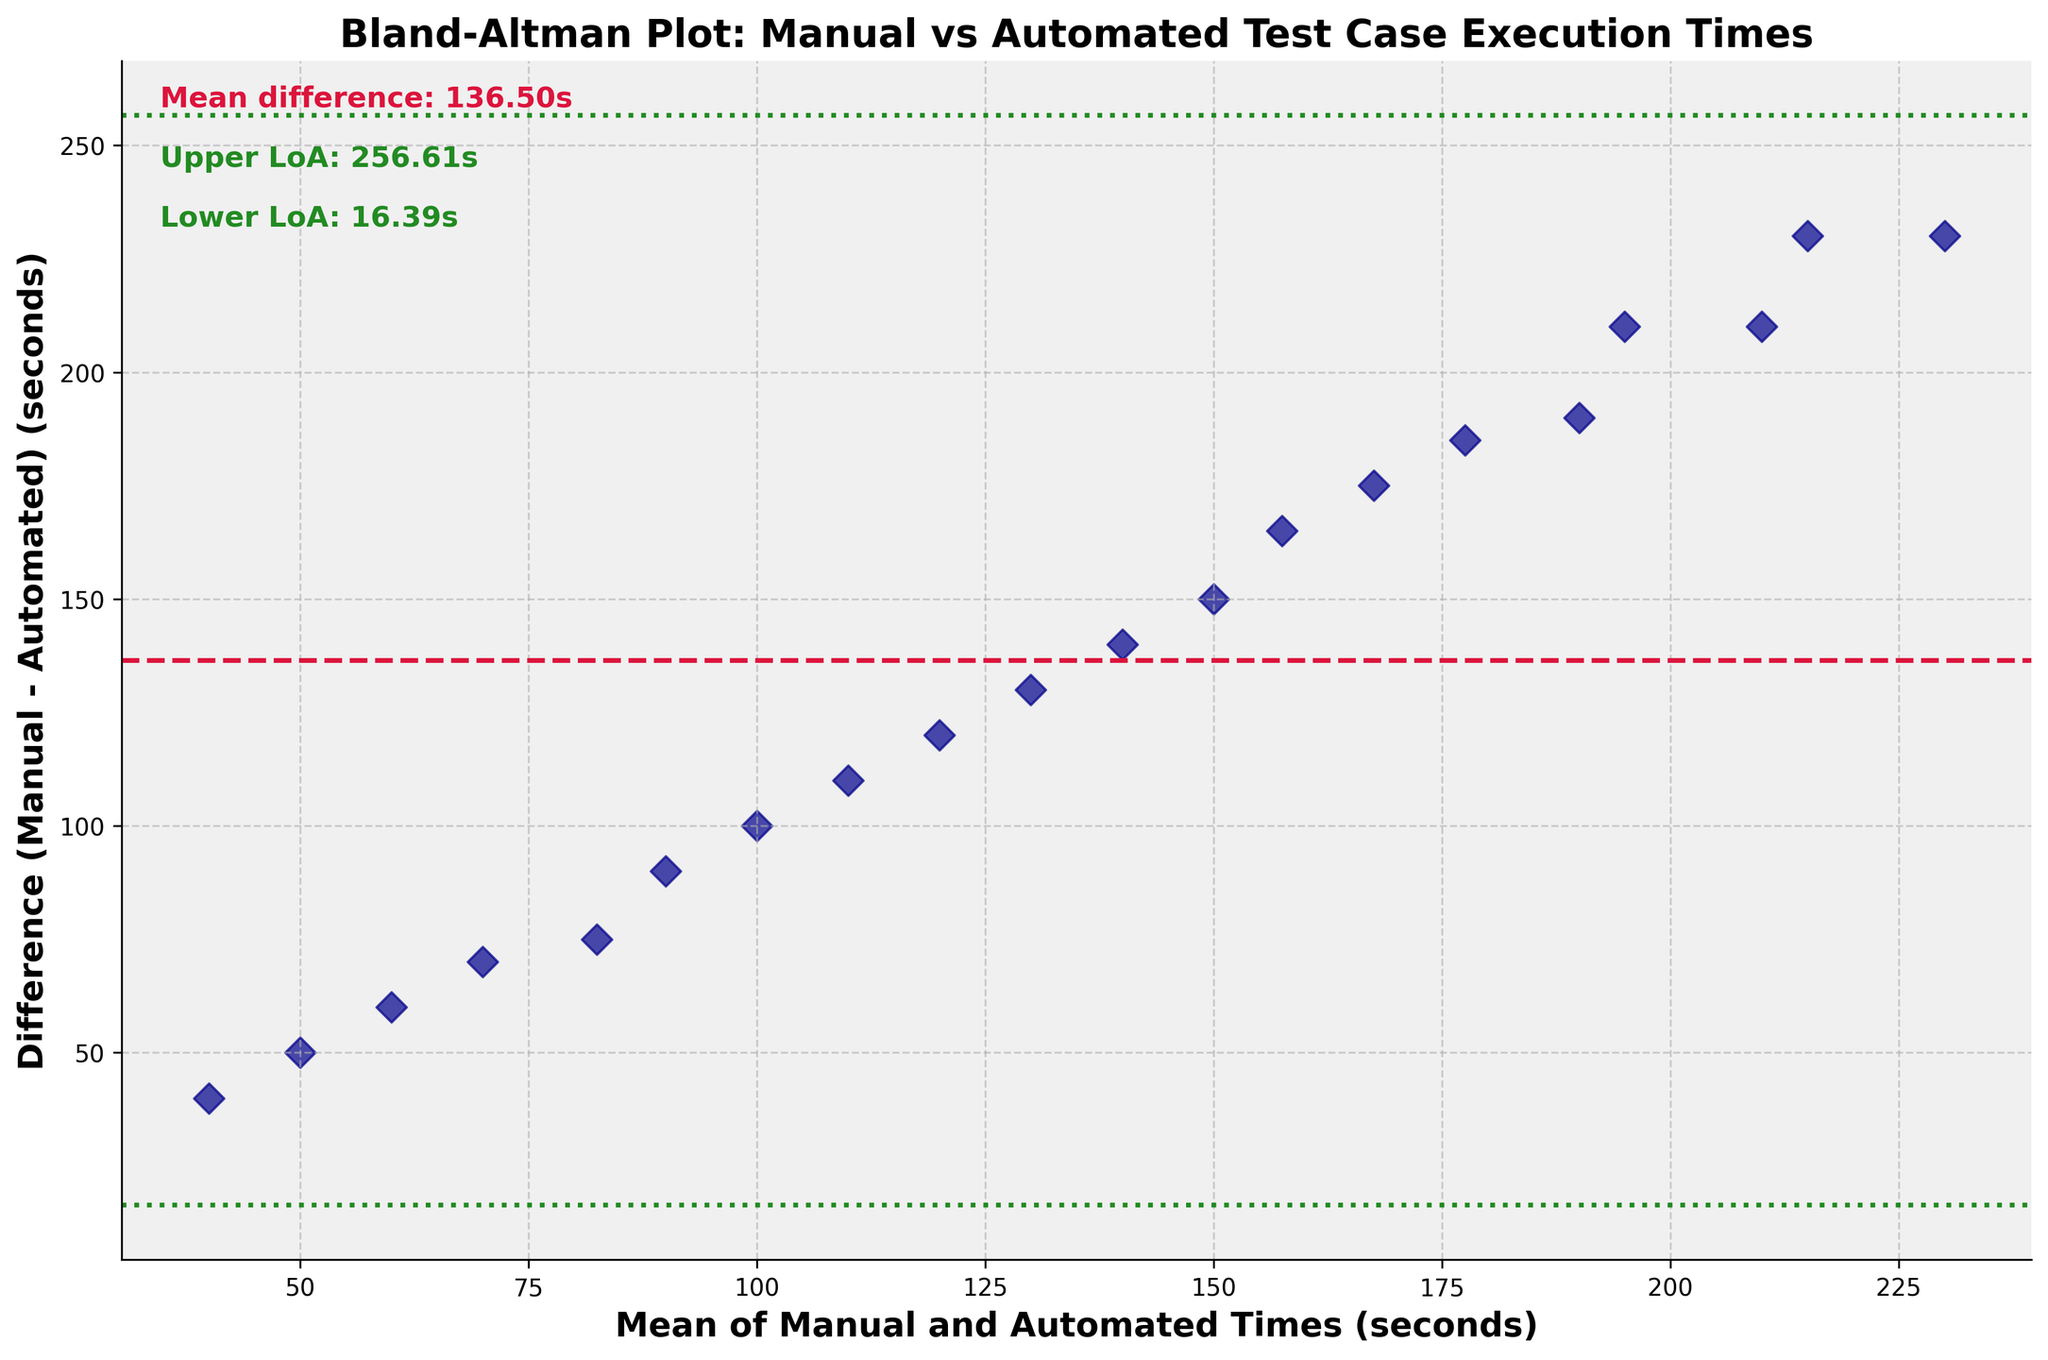What does the title of the plot indicate? The title "Bland-Altman Plot: Manual vs Automated Test Case Execution Times" indicates that this plot compares the execution times of test cases when run manually versus automatically.
Answer: It compares manual and automated test execution times How many data points are represented in the plot? By counting the individual dots scattered in the plot, one can see that there are 20 data points.
Answer: 20 What do the x-axis and y-axis represent in the plot? The x-axis represents the mean of manual and automated times in seconds, while the y-axis represents the difference between manual and automated times (manual time - automated time) in seconds.
Answer: Mean of times (x), Difference in times (y) What is the mean difference between manual and automated test execution times? The mean difference is represented by the horizontal dashed line, which is labeled as "Mean difference: 146.25s" on the plot.
Answer: 146.25 seconds Where are the limits of agreement situated, and what do they mean? The limits of agreement are indicated by the dotted lines: one at 0.77 seconds (Lower LoA) and the other at 291.73 seconds (Upper LoA). They represent the range within which most of the differences between manual and automated times lie.
Answer: 0.77 seconds (Lower LoA) and 291.73 seconds (Upper LoA) Is there any trend or pattern visible in the difference between manual and automated execution times as the mean time increases? By observing the scatter of the points, there doesn’t seem to be a defined trend or pattern; the differences appear random around the mean difference line without a clear increase or decrease trend as the mean time rises.
Answer: No clear trend Which test case has the largest difference between manual and automated execution times? By reviewing the y-axis for the farthest point from zero, we see that the point representing the largest difference is near 230 seconds. This corresponds to the "Shopping Cart" test case.
Answer: Shopping Cart Are there any test cases where the automated time is marginally close to the manual time? Yes, test cases near the lower limit of agreement (0.77 seconds) have execution times that are very close, indicating minimal difference. This can be observed with test cases around the lower green dotted line.
Answer: Yes What can be inferred if a data point lies outside the limits of agreement? If a data point lies outside the limits of agreement (below 0.77 seconds or above 291.73 seconds), it means the difference between manual and automated times for that test case is significantly larger or smaller than expected, indicating potential inconsistencies or anomalies in the execution times.
Answer: Significant inconsistency Based on the plot, is automated testing generally faster than manual testing for these cases? The plot shows that the majority of points have positive y-values, indicating that manual times are generally longer than automated times, thus confirming automated testing is typically faster.
Answer: Yes 